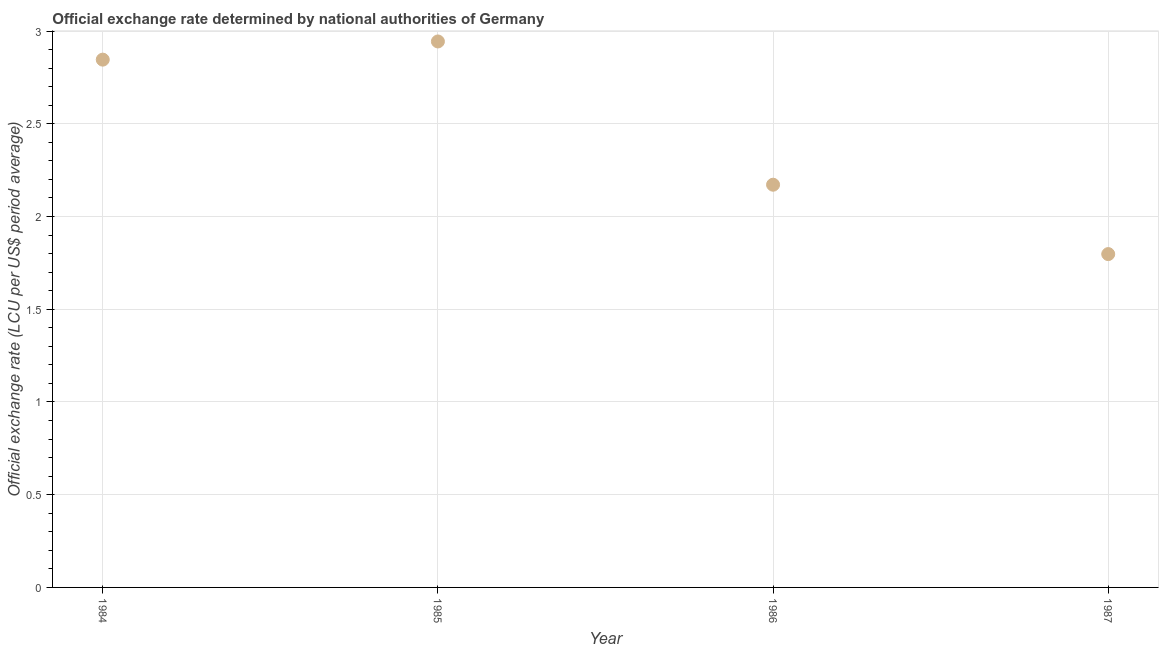What is the official exchange rate in 1984?
Offer a terse response. 2.85. Across all years, what is the maximum official exchange rate?
Make the answer very short. 2.94. Across all years, what is the minimum official exchange rate?
Give a very brief answer. 1.8. In which year was the official exchange rate minimum?
Offer a very short reply. 1987. What is the sum of the official exchange rate?
Give a very brief answer. 9.76. What is the difference between the official exchange rate in 1984 and 1987?
Offer a very short reply. 1.05. What is the average official exchange rate per year?
Offer a terse response. 2.44. What is the median official exchange rate?
Keep it short and to the point. 2.51. In how many years, is the official exchange rate greater than 1.8 ?
Your answer should be compact. 3. Do a majority of the years between 1984 and 1985 (inclusive) have official exchange rate greater than 0.8 ?
Ensure brevity in your answer.  Yes. What is the ratio of the official exchange rate in 1985 to that in 1986?
Keep it short and to the point. 1.36. Is the difference between the official exchange rate in 1986 and 1987 greater than the difference between any two years?
Your answer should be compact. No. What is the difference between the highest and the second highest official exchange rate?
Offer a very short reply. 0.1. Is the sum of the official exchange rate in 1985 and 1987 greater than the maximum official exchange rate across all years?
Give a very brief answer. Yes. What is the difference between the highest and the lowest official exchange rate?
Your answer should be compact. 1.15. In how many years, is the official exchange rate greater than the average official exchange rate taken over all years?
Provide a short and direct response. 2. How many years are there in the graph?
Your answer should be very brief. 4. Does the graph contain grids?
Ensure brevity in your answer.  Yes. What is the title of the graph?
Your answer should be very brief. Official exchange rate determined by national authorities of Germany. What is the label or title of the Y-axis?
Your answer should be very brief. Official exchange rate (LCU per US$ period average). What is the Official exchange rate (LCU per US$ period average) in 1984?
Ensure brevity in your answer.  2.85. What is the Official exchange rate (LCU per US$ period average) in 1985?
Provide a short and direct response. 2.94. What is the Official exchange rate (LCU per US$ period average) in 1986?
Keep it short and to the point. 2.17. What is the Official exchange rate (LCU per US$ period average) in 1987?
Make the answer very short. 1.8. What is the difference between the Official exchange rate (LCU per US$ period average) in 1984 and 1985?
Keep it short and to the point. -0.1. What is the difference between the Official exchange rate (LCU per US$ period average) in 1984 and 1986?
Your response must be concise. 0.67. What is the difference between the Official exchange rate (LCU per US$ period average) in 1984 and 1987?
Keep it short and to the point. 1.05. What is the difference between the Official exchange rate (LCU per US$ period average) in 1985 and 1986?
Your answer should be very brief. 0.77. What is the difference between the Official exchange rate (LCU per US$ period average) in 1985 and 1987?
Ensure brevity in your answer.  1.15. What is the difference between the Official exchange rate (LCU per US$ period average) in 1986 and 1987?
Keep it short and to the point. 0.37. What is the ratio of the Official exchange rate (LCU per US$ period average) in 1984 to that in 1986?
Your response must be concise. 1.31. What is the ratio of the Official exchange rate (LCU per US$ period average) in 1984 to that in 1987?
Give a very brief answer. 1.58. What is the ratio of the Official exchange rate (LCU per US$ period average) in 1985 to that in 1986?
Offer a terse response. 1.36. What is the ratio of the Official exchange rate (LCU per US$ period average) in 1985 to that in 1987?
Keep it short and to the point. 1.64. What is the ratio of the Official exchange rate (LCU per US$ period average) in 1986 to that in 1987?
Your answer should be very brief. 1.21. 